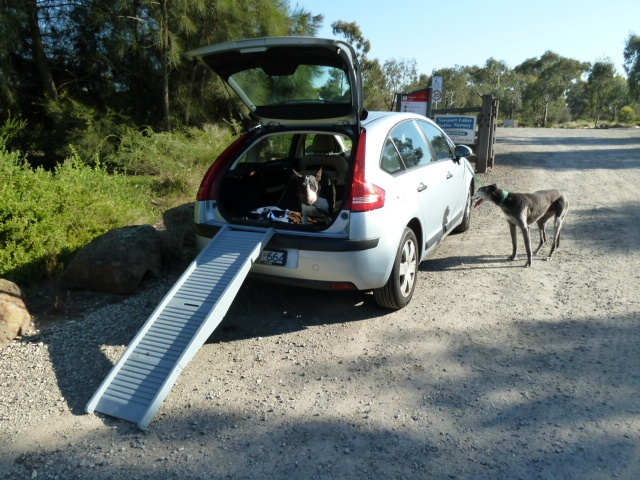Describe the objects in this image and their specific colors. I can see car in black, white, gray, and darkgray tones, dog in black, gray, and darkgray tones, and dog in black, gray, darkgray, and ivory tones in this image. 